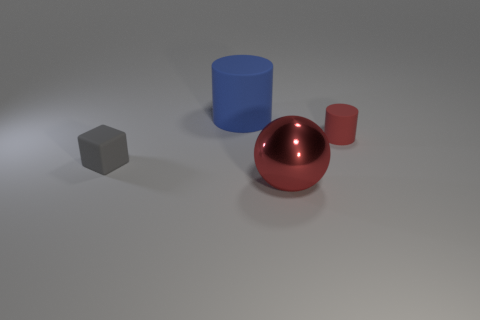Add 2 red metallic things. How many objects exist? 6 Subtract all cubes. How many objects are left? 3 Subtract 0 brown blocks. How many objects are left? 4 Subtract all red rubber cylinders. Subtract all gray matte objects. How many objects are left? 2 Add 3 large red objects. How many large red objects are left? 4 Add 1 purple metallic spheres. How many purple metallic spheres exist? 1 